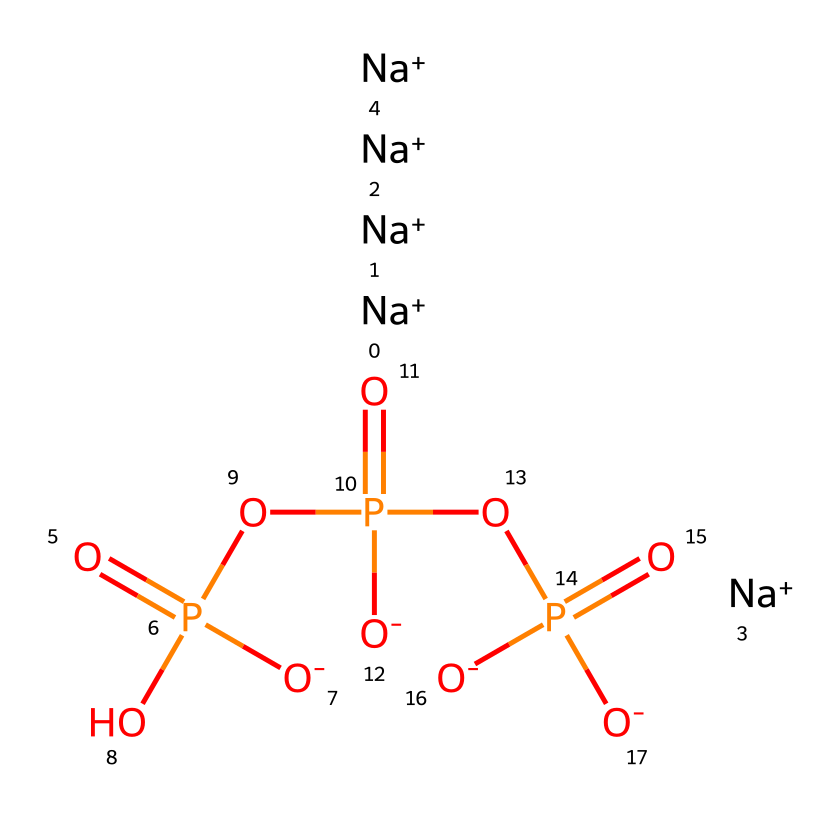What is the total number of sodium ions in this chemical? The SMILES representation shows five instances of sodium ions indicated by "[Na+]". Counting these gives a total of five sodium ions.
Answer: five How many phosphorus atoms are present in this structure? In the SMILES representation, the phosphorus atoms are indicated by "P". There are three occurrences of "P" in the structure, so there are three phosphorus atoms.
Answer: three What type of bond connects the phosphorus and oxygen atoms? The phosphorus and oxygen atoms in this molecule are connected by covalent bonds, which involve the sharing of electrons. This is characteristic of the structure of phosphates.
Answer: covalent What can be inferred about the solubility of sodium triphosphate in water? Sodium triphosphate contains sodium ions, which are highly soluble in water, and the presence of phosphate groups also enhances solubility due to their ionic nature. Therefore, sodium triphosphate is expected to be soluble in water.
Answer: soluble Which functional group is primarily responsible for the anti-corrosion properties of sodium triphosphate? The phosphate groups in sodium triphosphate help to form protective layers on metal surfaces, reducing corrosion. These phosphate groups are responsible for the anti-corrosion effect.
Answer: phosphate groups What is the charge of the oxygen atoms in this chemical? The SMILES representation indicates the oxygen atoms connected to sodium ions are negatively charged as shown by "[O-]", suggesting that they carry a negative charge.
Answer: negative How many total oxygen atoms are in sodium triphosphate? The structure shows seven oxygen atoms: four are indicated directly in the "O" or "[O-]" parts and three as they are connected to each phosphorus atom in the phosphate groups.
Answer: seven 